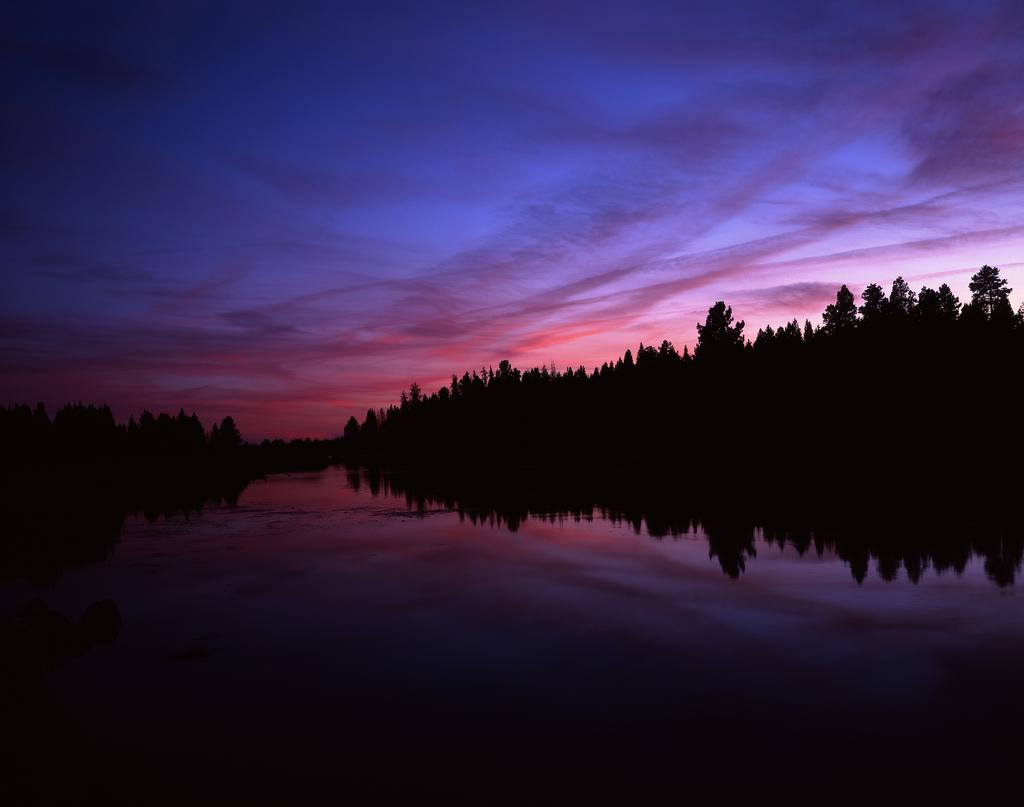What is the main feature in the foreground of the picture? There is a water body in the foreground of the picture. What can be seen in the middle of the picture? There are trees in the center of the picture. What is visible in the background of the picture? The sky is visible in the background of the picture. Can you tell me how many pairs of scissors are floating in the water body in the image? There are no scissors present in the image; it features a water body, trees, and the sky. What type of natural disaster is happening in the image? There is no indication of a natural disaster, such as an earthquake, in the image. 